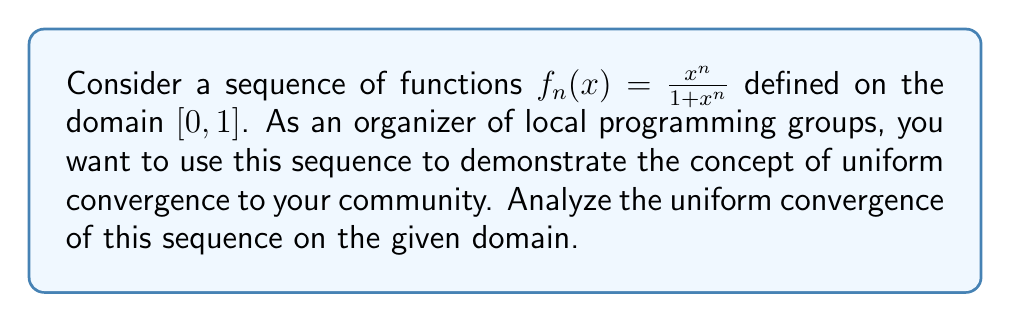Help me with this question. To analyze the uniform convergence of the sequence $f_n(x) = \frac{x^n}{1+x^n}$ on $[0,1]$, we'll follow these steps:

1) First, let's find the pointwise limit of the sequence:
   For $x \in [0,1)$, $\lim_{n \to \infty} x^n = 0$, so $\lim_{n \to \infty} f_n(x) = 0$
   For $x = 1$, $\lim_{n \to \infty} f_n(1) = \lim_{n \to \infty} \frac{1}{2} = \frac{1}{2}$

   Therefore, the pointwise limit function is:
   $$f(x) = \begin{cases} 
   0 & \text{if } x \in [0,1) \\
   \frac{1}{2} & \text{if } x = 1
   \end{cases}$$

2) For uniform convergence, we need to examine:
   $$\sup_{x \in [0,1]} |f_n(x) - f(x)|$$

3) Let's consider $|f_n(x) - f(x)|$ for $x \in [0,1)$:
   $$|f_n(x) - f(x)| = |\frac{x^n}{1+x^n} - 0| = \frac{x^n}{1+x^n}$$

4) For $x = 1$:
   $$|f_n(1) - f(1)| = |\frac{1}{2} - \frac{1}{2}| = 0$$

5) The supremum will occur at $x = 1$, because $\frac{x^n}{1+x^n}$ is increasing on $[0,1]$:
   $$\sup_{x \in [0,1]} |f_n(x) - f(x)| = \frac{1}{2}$$

6) As this supremum does not approach 0 as $n \to \infty$, the sequence does not converge uniformly on $[0,1]$.

7) However, if we consider any closed interval $[0,a]$ where $0 \leq a < 1$, then:
   $$\sup_{x \in [0,a]} |f_n(x) - f(x)| = \frac{a^n}{1+a^n} \to 0 \text{ as } n \to \infty$$

   This means the sequence converges uniformly on any closed subinterval $[0,a]$ of $[0,1)$.
Answer: The sequence $f_n(x) = \frac{x^n}{1+x^n}$ does not converge uniformly on $[0,1]$. However, it does converge uniformly on any closed subinterval $[0,a]$ where $0 \leq a < 1$. 